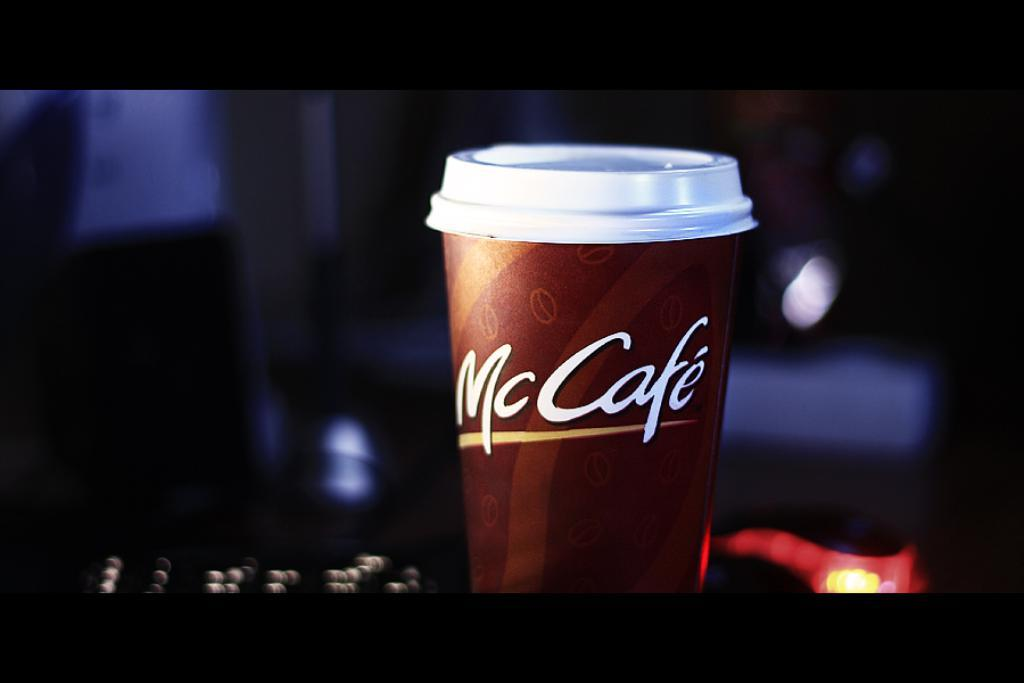<image>
Write a terse but informative summary of the picture. A cup with a lid that says McCafe. 